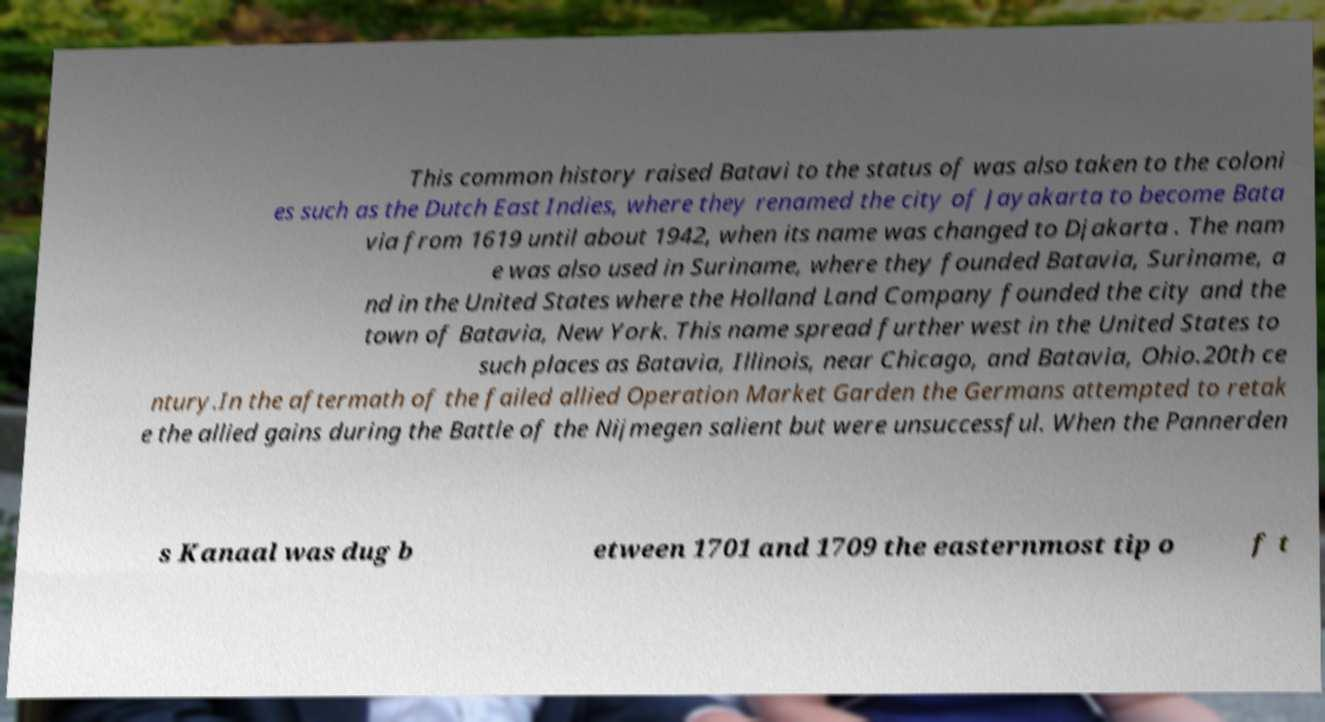Please read and relay the text visible in this image. What does it say? This common history raised Batavi to the status of was also taken to the coloni es such as the Dutch East Indies, where they renamed the city of Jayakarta to become Bata via from 1619 until about 1942, when its name was changed to Djakarta . The nam e was also used in Suriname, where they founded Batavia, Suriname, a nd in the United States where the Holland Land Company founded the city and the town of Batavia, New York. This name spread further west in the United States to such places as Batavia, Illinois, near Chicago, and Batavia, Ohio.20th ce ntury.In the aftermath of the failed allied Operation Market Garden the Germans attempted to retak e the allied gains during the Battle of the Nijmegen salient but were unsuccessful. When the Pannerden s Kanaal was dug b etween 1701 and 1709 the easternmost tip o f t 